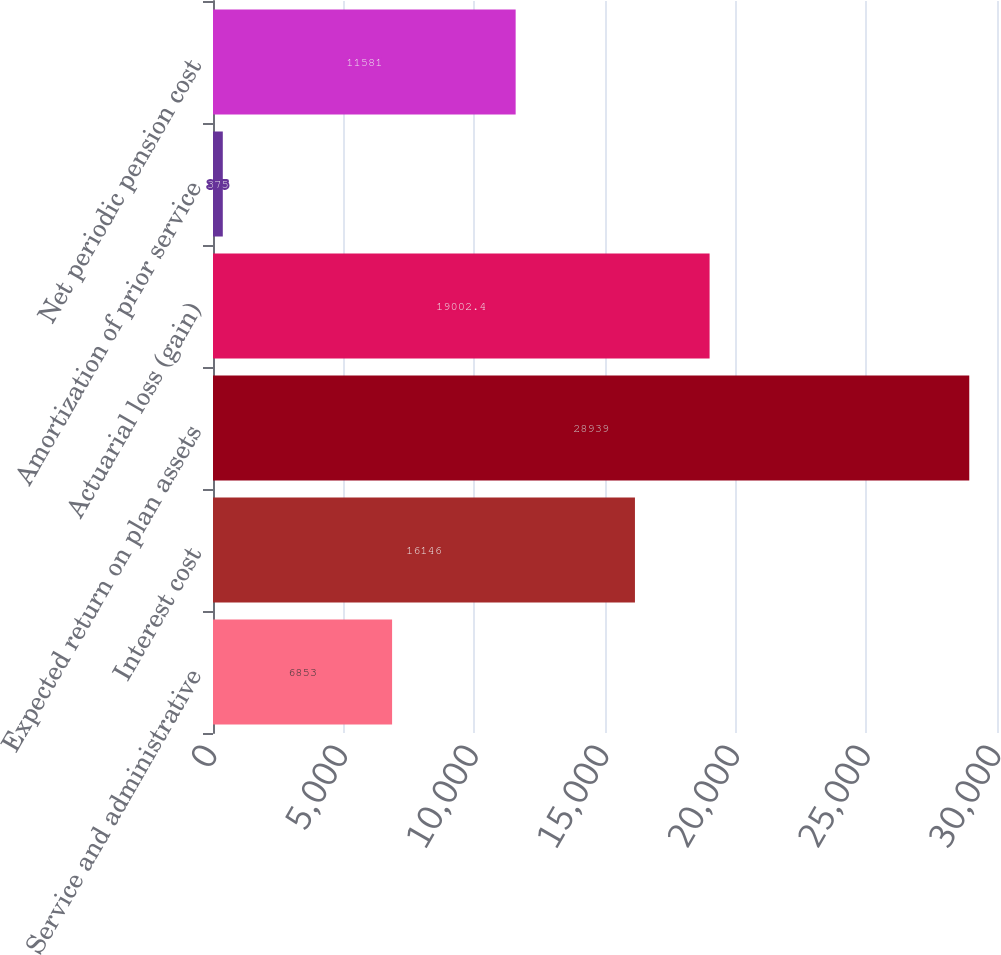Convert chart. <chart><loc_0><loc_0><loc_500><loc_500><bar_chart><fcel>Service and administrative<fcel>Interest cost<fcel>Expected return on plan assets<fcel>Actuarial loss (gain)<fcel>Amortization of prior service<fcel>Net periodic pension cost<nl><fcel>6853<fcel>16146<fcel>28939<fcel>19002.4<fcel>375<fcel>11581<nl></chart> 